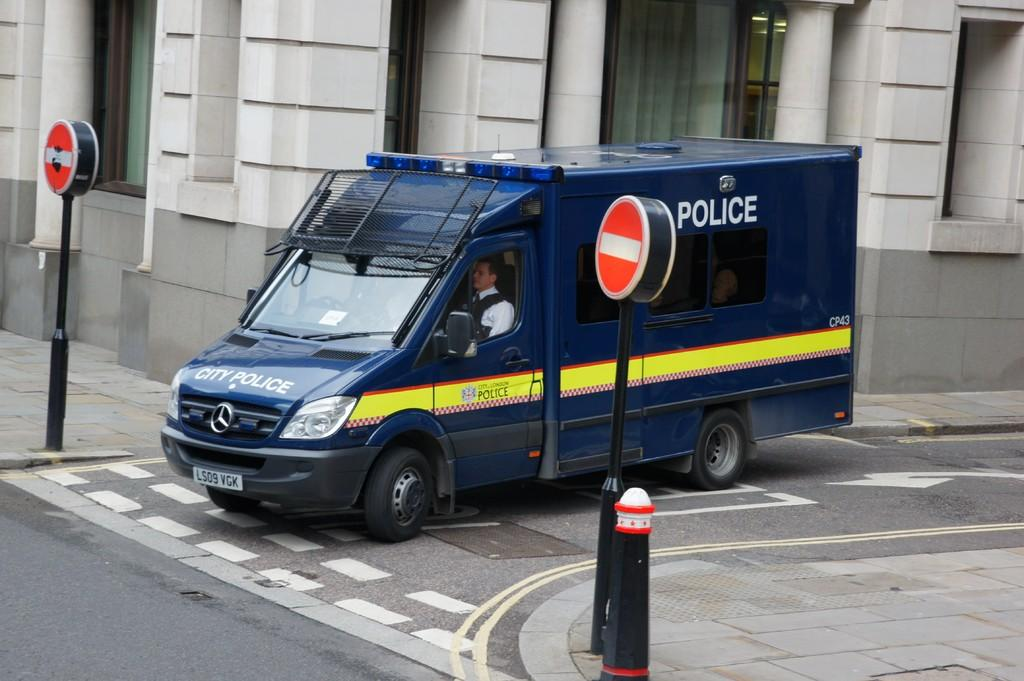<image>
Describe the image concisely. a large box type truck going down the street says police on it 